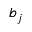<formula> <loc_0><loc_0><loc_500><loc_500>b _ { j }</formula> 